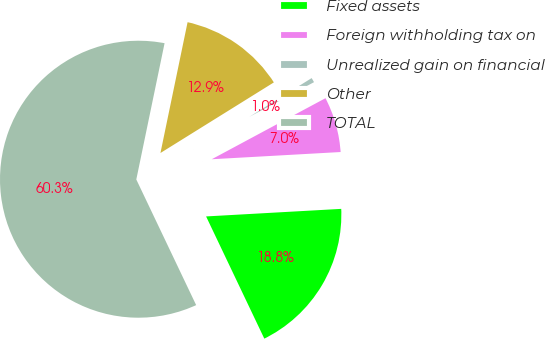Convert chart to OTSL. <chart><loc_0><loc_0><loc_500><loc_500><pie_chart><fcel>Fixed assets<fcel>Foreign withholding tax on<fcel>Unrealized gain on financial<fcel>Other<fcel>TOTAL<nl><fcel>18.81%<fcel>6.95%<fcel>1.02%<fcel>12.88%<fcel>60.32%<nl></chart> 